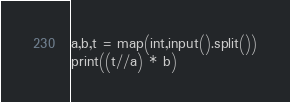<code> <loc_0><loc_0><loc_500><loc_500><_Python_>a,b,t = map(int,input().split())
print((t//a) * b)</code> 